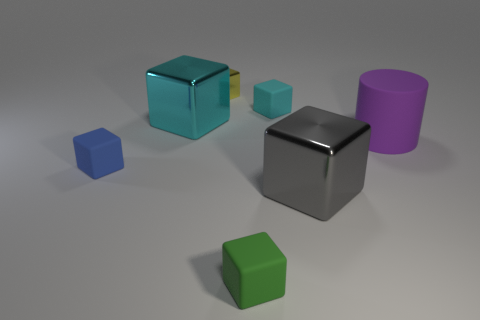Which objects in the image appear to have a reflective surface? In the image, the silver cube in the center and the purple cylinder on the right exhibit reflective surfaces, as indicated by the visible light glare and highlights that suggest a level of glossiness. 